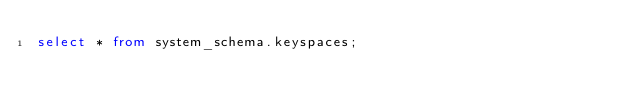<code> <loc_0><loc_0><loc_500><loc_500><_SQL_>select * from system_schema.keyspaces;</code> 